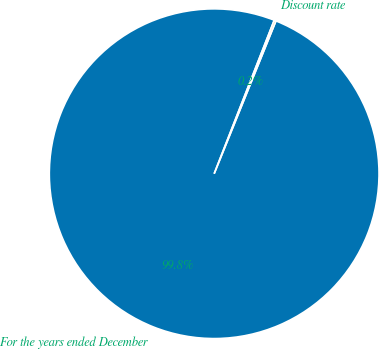Convert chart to OTSL. <chart><loc_0><loc_0><loc_500><loc_500><pie_chart><fcel>For the years ended December<fcel>Discount rate<nl><fcel>99.82%<fcel>0.18%<nl></chart> 